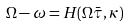Convert formula to latex. <formula><loc_0><loc_0><loc_500><loc_500>\Omega - \omega = H ( \Omega \bar { \tau } , \kappa )</formula> 